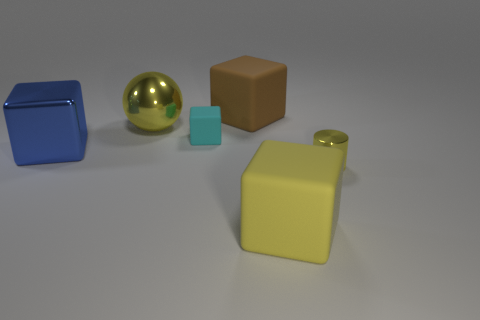Subtract all tiny cyan matte blocks. How many blocks are left? 3 Add 2 green cubes. How many objects exist? 8 Subtract all spheres. How many objects are left? 5 Subtract 2 cubes. How many cubes are left? 2 Subtract all green cylinders. Subtract all brown balls. How many cylinders are left? 1 Subtract all yellow cylinders. Subtract all large metallic blocks. How many objects are left? 4 Add 6 big brown blocks. How many big brown blocks are left? 7 Add 6 small brown metal balls. How many small brown metal balls exist? 6 Subtract all cyan cubes. How many cubes are left? 3 Subtract 0 purple blocks. How many objects are left? 6 